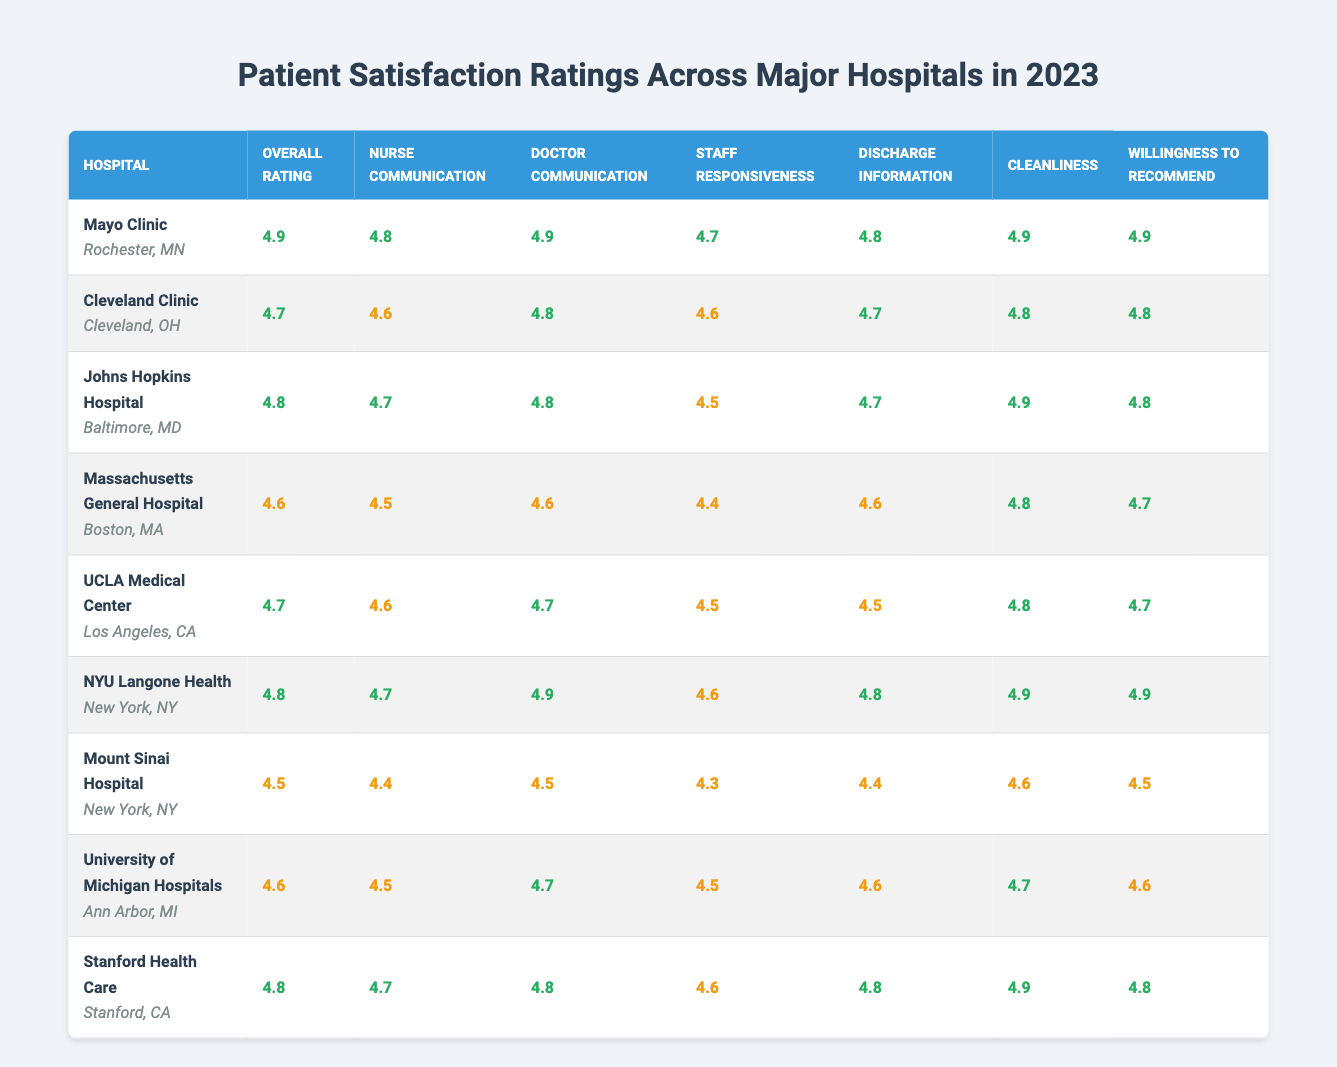What hospital has the highest overall rating? By reviewing the "Overall Rating" column in the table, Mayo Clinic has the highest rating at 4.9.
Answer: Mayo Clinic What is the communication with nurses rating for Johns Hopkins Hospital? The table shows that the communication with nurses rating for Johns Hopkins Hospital is 4.7.
Answer: 4.7 Which hospital has the lowest cleanliness rating, and what is that rating? Looking at the "Cleanliness" column, Mount Sinai Hospital has the lowest cleanliness rating of 4.6.
Answer: Mount Sinai Hospital, 4.6 What is the average overall rating of the top three hospitals? The overall ratings for the top three hospitals (Mayo Clinic, Johns Hopkins Hospital, and NYU Langone Health) are 4.9, 4.8, and 4.8 respectively. Their total is 4.9 + 4.8 + 4.8 = 14.5, and the average is 14.5 / 3 = 4.83.
Answer: 4.83 Is the willingness to recommend rating for UCLA Medical Center higher than for Massachusetts General Hospital? UCLA Medical Center has a willingness to recommend rating of 4.7, while Massachusetts General Hospital's rating is 4.7 as well. Since they are equal, the statement is false.
Answer: No What is the difference in nurse communication rating between Cleveland Clinic and University of Michigan Hospitals? The nurse communication rating for Cleveland Clinic is 4.6, and for University of Michigan Hospitals, it's 4.5. The difference is 4.6 - 4.5 = 0.1.
Answer: 0.1 Are the ratings for staff responsiveness at NYU Langone Health and Massachusetts General Hospital the same? The table shows that NYU Langone Health has a responsiveness rating of 4.6 and Massachusetts General Hospital has a rating of 4.4. Since they differ, the answer is no.
Answer: No What hospital received a higher discharge information rating: John Hopkins Hospital or Cleveland Clinic? Johns Hopkins Hospital received a discharge information rating of 4.7, while Cleveland Clinic received a rating of 4.7 as well; therefore, they are equal.
Answer: They are equal Which hospital has a higher rating for doctor communication: Mount Sinai Hospital or UCLA Medical Center? Mount Sinai Hospital's doctor communication rating is 4.5, while UCLA Medical Center's rating is 4.7. Thus, UCLA Medical Center has the higher rating.
Answer: UCLA Medical Center 